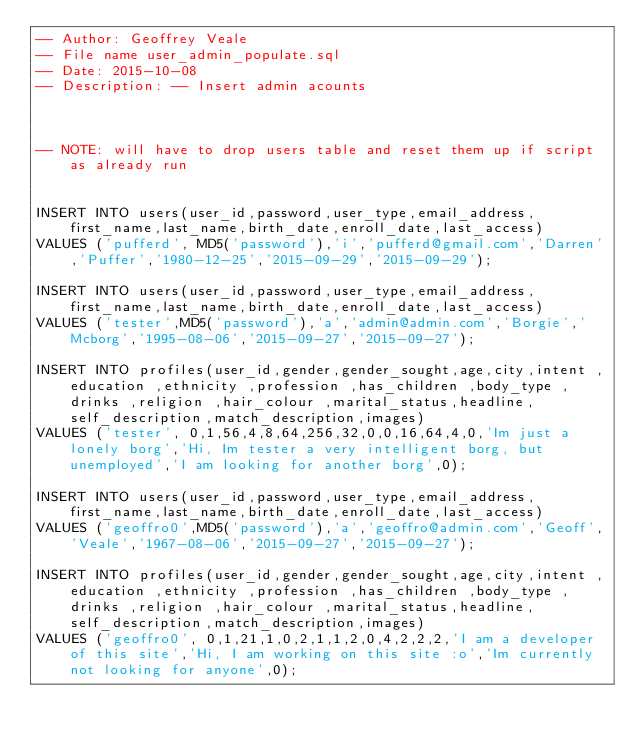<code> <loc_0><loc_0><loc_500><loc_500><_SQL_>-- Author: Geoffrey Veale
-- File name user_admin_populate.sql
-- Date: 2015-10-08
-- Description: -- Insert admin acounts 



-- NOTE: will have to drop users table and reset them up if script as already run  


INSERT INTO users(user_id,password,user_type,email_address, first_name,last_name,birth_date,enroll_date,last_access)
VALUES ('pufferd', MD5('password'),'i','pufferd@gmail.com','Darren','Puffer','1980-12-25','2015-09-29','2015-09-29');

INSERT INTO users(user_id,password,user_type,email_address, first_name,last_name,birth_date,enroll_date,last_access)
VALUES ('tester',MD5('password'),'a','admin@admin.com','Borgie','Mcborg','1995-08-06','2015-09-27','2015-09-27');

INSERT INTO profiles(user_id,gender,gender_sought,age,city,intent ,education ,ethnicity ,profession ,has_children ,body_type ,drinks ,religion ,hair_colour ,marital_status,headline,self_description,match_description,images)
VALUES ('tester', 0,1,56,4,8,64,256,32,0,0,16,64,4,0,'Im just a lonely borg','Hi, Im tester a very intelligent borg, but unemployed','I am looking for another borg',0);

INSERT INTO users(user_id,password,user_type,email_address, first_name,last_name,birth_date,enroll_date,last_access)
VALUES ('geoffro0',MD5('password'),'a','geoffro@admin.com','Geoff','Veale','1967-08-06','2015-09-27','2015-09-27');

INSERT INTO profiles(user_id,gender,gender_sought,age,city,intent ,education ,ethnicity ,profession ,has_children ,body_type ,drinks ,religion ,hair_colour ,marital_status,headline,self_description,match_description,images)
VALUES ('geoffro0', 0,1,21,1,0,2,1,1,2,0,4,2,2,2,'I am a developer of this site','Hi, I am working on this site :o','Im currently not looking for anyone',0);















</code> 